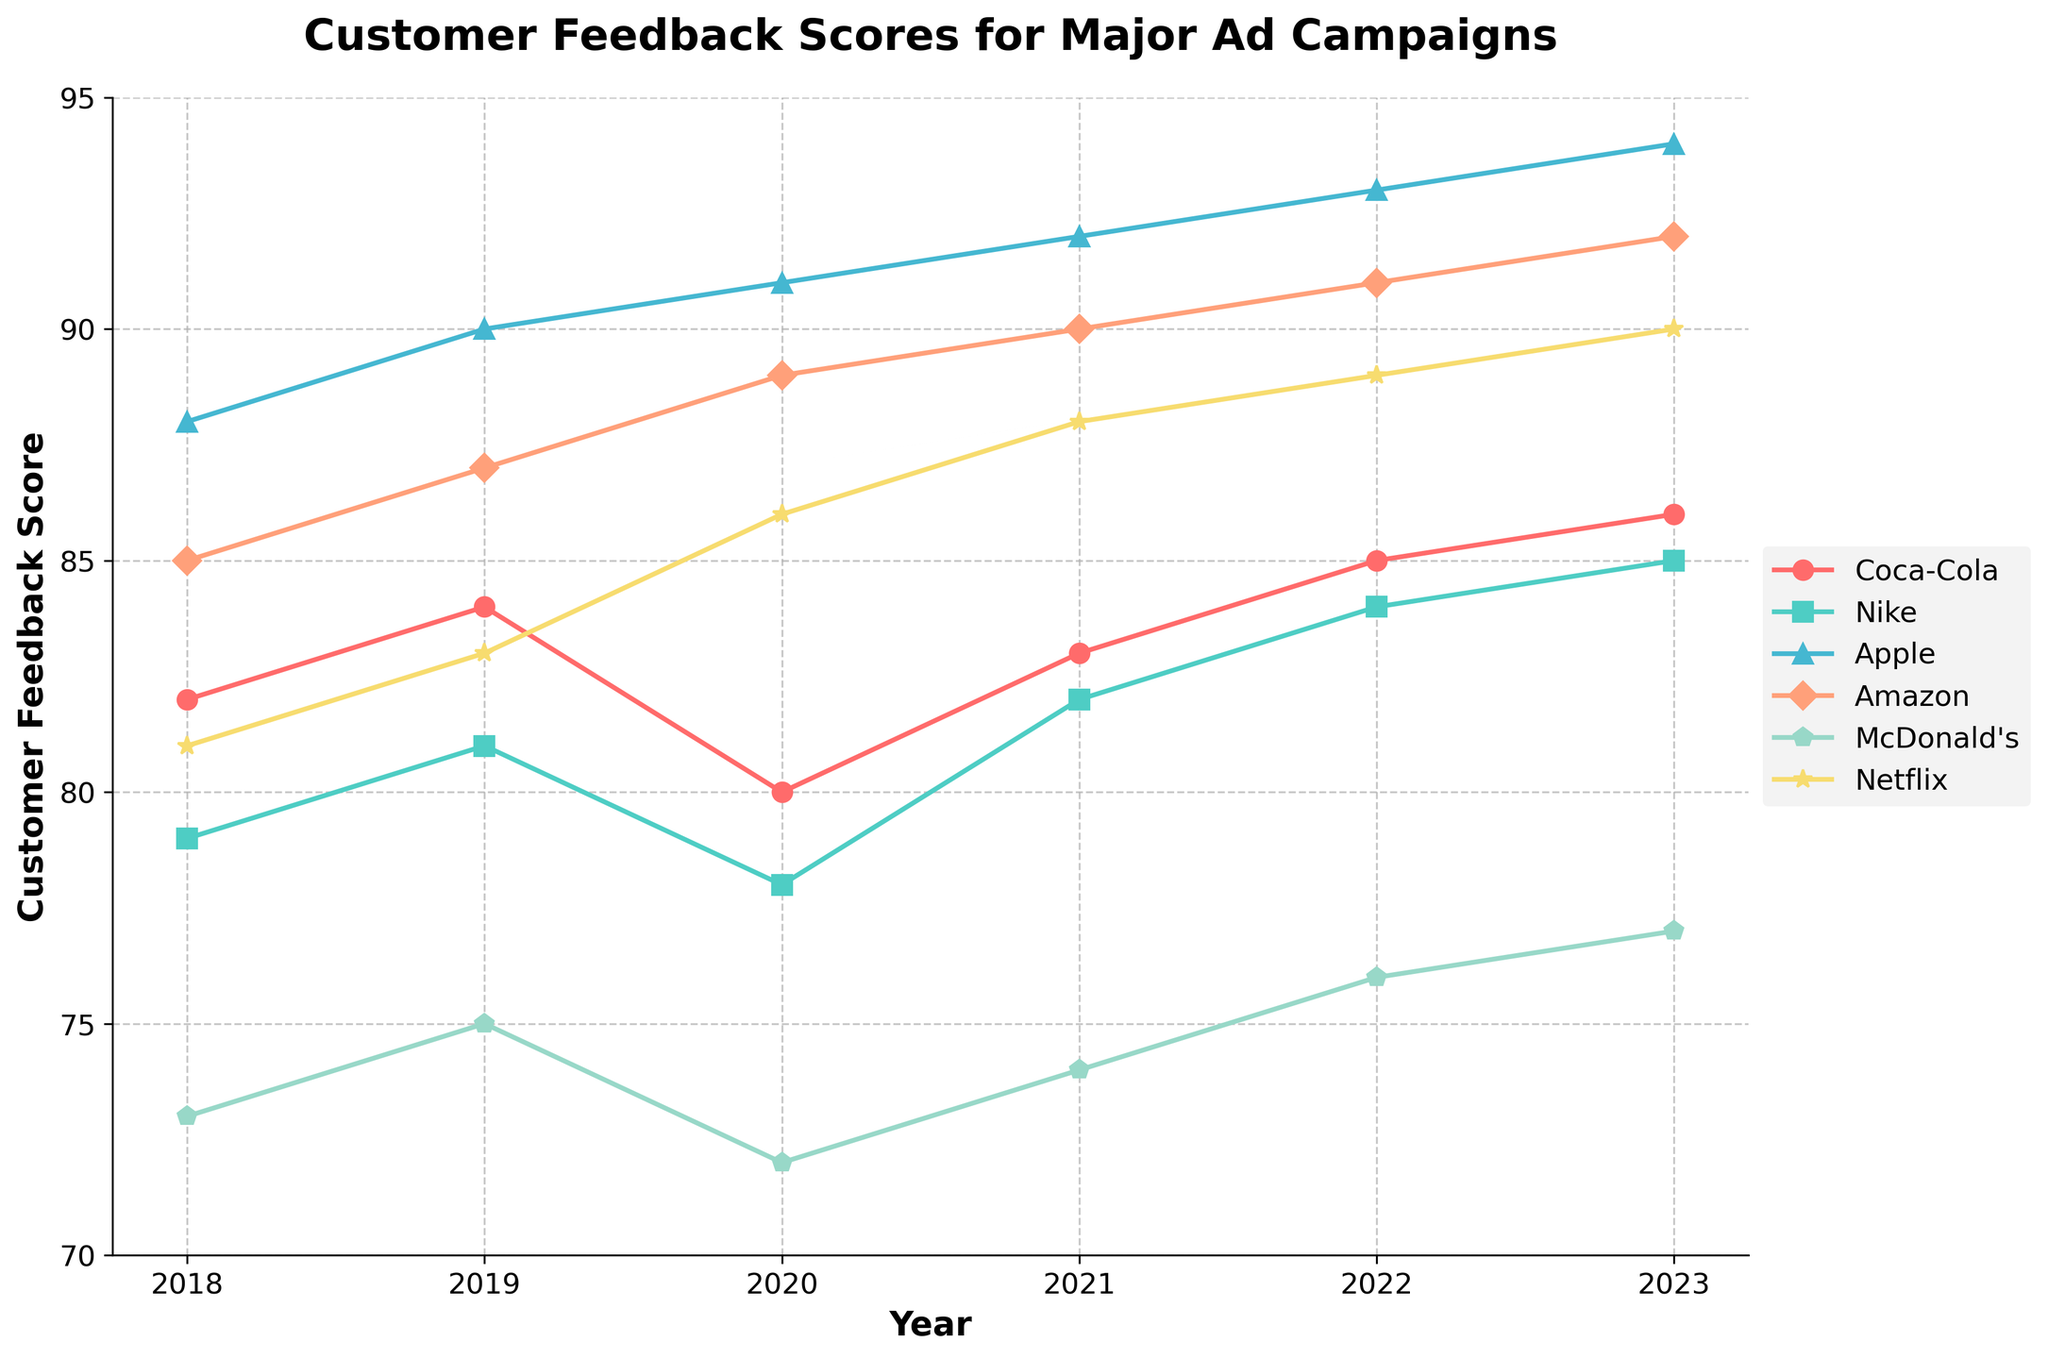Which brand had the highest customer feedback score in 2023? From the figure, find the highest data point on the y-axis for the year 2023 and match it with the corresponding brand label on the legend.
Answer: Apple Which brand had the lowest customer feedback score in 2018? Locate the data points for the year 2018 and determine which brand's score is at the lowest position on the y-axis.
Answer: McDonald's How did Netflix's customer feedback score change from 2018 to 2023? Identify the data points for Netflix in 2018 and 2023, and calculate the difference between them. Netflix's score increased from 81 in 2018 to 90 in 2023.
Answer: Increased by 9 Which brand had the most significant increase in customer feedback score from 2018 to 2023? For each brand, subtract the 2018 score from the 2023 score and determine which one has the largest positive change.
Answer: Netflix Compare the customer feedback scores of Apple and Coca-Cola in 2022. Which brand scored higher and by how much? Find the data points for Apple and Coca-Cola in 2022 and subtract Coca-Cola's score from Apple's score to determine which is higher and the difference.
Answer: Apple scored higher by 8 points What is the average customer feedback score for Nike over the years 2018 to 2023? Sum all the feedback scores for Nike from 2018 to 2023 and divide by the number of years (6). (79 + 81 + 78 + 82 + 84 + 85) / 6 = 81.5
Answer: 81.5 Which brand had a consistent increase in customer feedback scores every year from 2018 to 2023? For each brand, check if the feedback score increased every year from 2018 to 2023 without any decline.
Answer: Apple Find the year in which Amazon had the greatest increase in customer feedback score compared to the previous year. Calculate the year-to-year differences in Amazon's feedback scores and identify the year with the largest increase. The differences are: 2019 (87-85 = 2), 2020 (89-87 = 2), 2021 (90-89 = 1), 2022 (91-90 = 1), 2023 (92-91 = 1).
Answer: 2019 and 2020 (tie) Which brand's customer feedback score had the smallest range (difference between the highest and lowest scores) from 2018 to 2023? For each brand, determine the range of scores by subtracting the lowest score from the highest score across the years 2018 to 2023, and identify the brand with the smallest range. Coca-Cola's range is 86-80=6, Nike's is 85-78=7, Apple's is 94-88=6, Amazon's is 92-85=7, McDonald's is 77-72=5, and Netflix's is 90-81=9.
Answer: McDonald's Of the brands compared, which one had the highest average customer feedback score over the entire period? Calculate the average score for each brand across the years 2018 to 2023 and determine which brand has the highest average. Apple's average is (88+90+91+92+93+94)/6 = 91.33, the highest among the brands.
Answer: Apple 